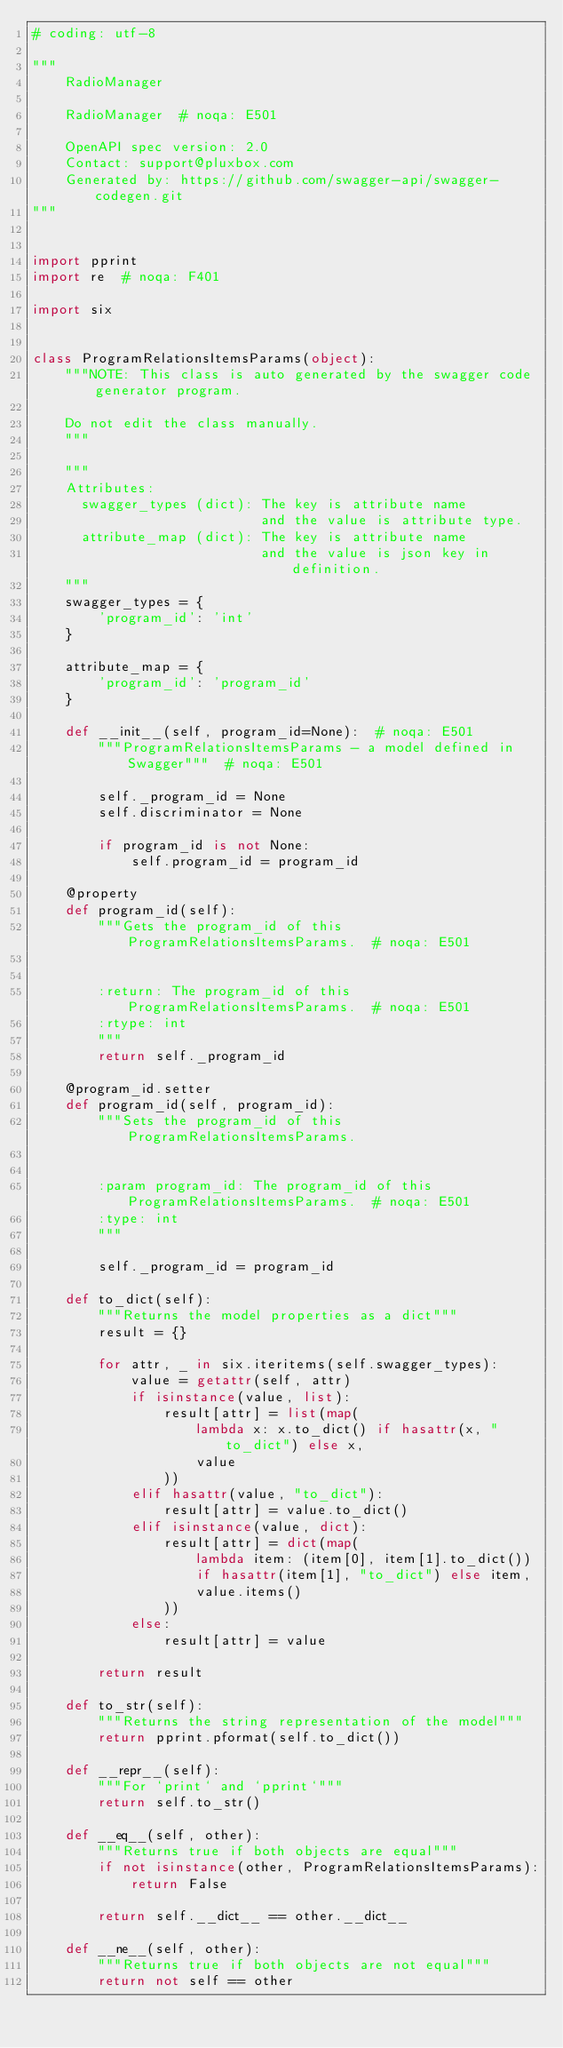Convert code to text. <code><loc_0><loc_0><loc_500><loc_500><_Python_># coding: utf-8

"""
    RadioManager

    RadioManager  # noqa: E501

    OpenAPI spec version: 2.0
    Contact: support@pluxbox.com
    Generated by: https://github.com/swagger-api/swagger-codegen.git
"""


import pprint
import re  # noqa: F401

import six


class ProgramRelationsItemsParams(object):
    """NOTE: This class is auto generated by the swagger code generator program.

    Do not edit the class manually.
    """

    """
    Attributes:
      swagger_types (dict): The key is attribute name
                            and the value is attribute type.
      attribute_map (dict): The key is attribute name
                            and the value is json key in definition.
    """
    swagger_types = {
        'program_id': 'int'
    }

    attribute_map = {
        'program_id': 'program_id'
    }

    def __init__(self, program_id=None):  # noqa: E501
        """ProgramRelationsItemsParams - a model defined in Swagger"""  # noqa: E501

        self._program_id = None
        self.discriminator = None

        if program_id is not None:
            self.program_id = program_id

    @property
    def program_id(self):
        """Gets the program_id of this ProgramRelationsItemsParams.  # noqa: E501


        :return: The program_id of this ProgramRelationsItemsParams.  # noqa: E501
        :rtype: int
        """
        return self._program_id

    @program_id.setter
    def program_id(self, program_id):
        """Sets the program_id of this ProgramRelationsItemsParams.


        :param program_id: The program_id of this ProgramRelationsItemsParams.  # noqa: E501
        :type: int
        """

        self._program_id = program_id

    def to_dict(self):
        """Returns the model properties as a dict"""
        result = {}

        for attr, _ in six.iteritems(self.swagger_types):
            value = getattr(self, attr)
            if isinstance(value, list):
                result[attr] = list(map(
                    lambda x: x.to_dict() if hasattr(x, "to_dict") else x,
                    value
                ))
            elif hasattr(value, "to_dict"):
                result[attr] = value.to_dict()
            elif isinstance(value, dict):
                result[attr] = dict(map(
                    lambda item: (item[0], item[1].to_dict())
                    if hasattr(item[1], "to_dict") else item,
                    value.items()
                ))
            else:
                result[attr] = value

        return result

    def to_str(self):
        """Returns the string representation of the model"""
        return pprint.pformat(self.to_dict())

    def __repr__(self):
        """For `print` and `pprint`"""
        return self.to_str()

    def __eq__(self, other):
        """Returns true if both objects are equal"""
        if not isinstance(other, ProgramRelationsItemsParams):
            return False

        return self.__dict__ == other.__dict__

    def __ne__(self, other):
        """Returns true if both objects are not equal"""
        return not self == other
</code> 